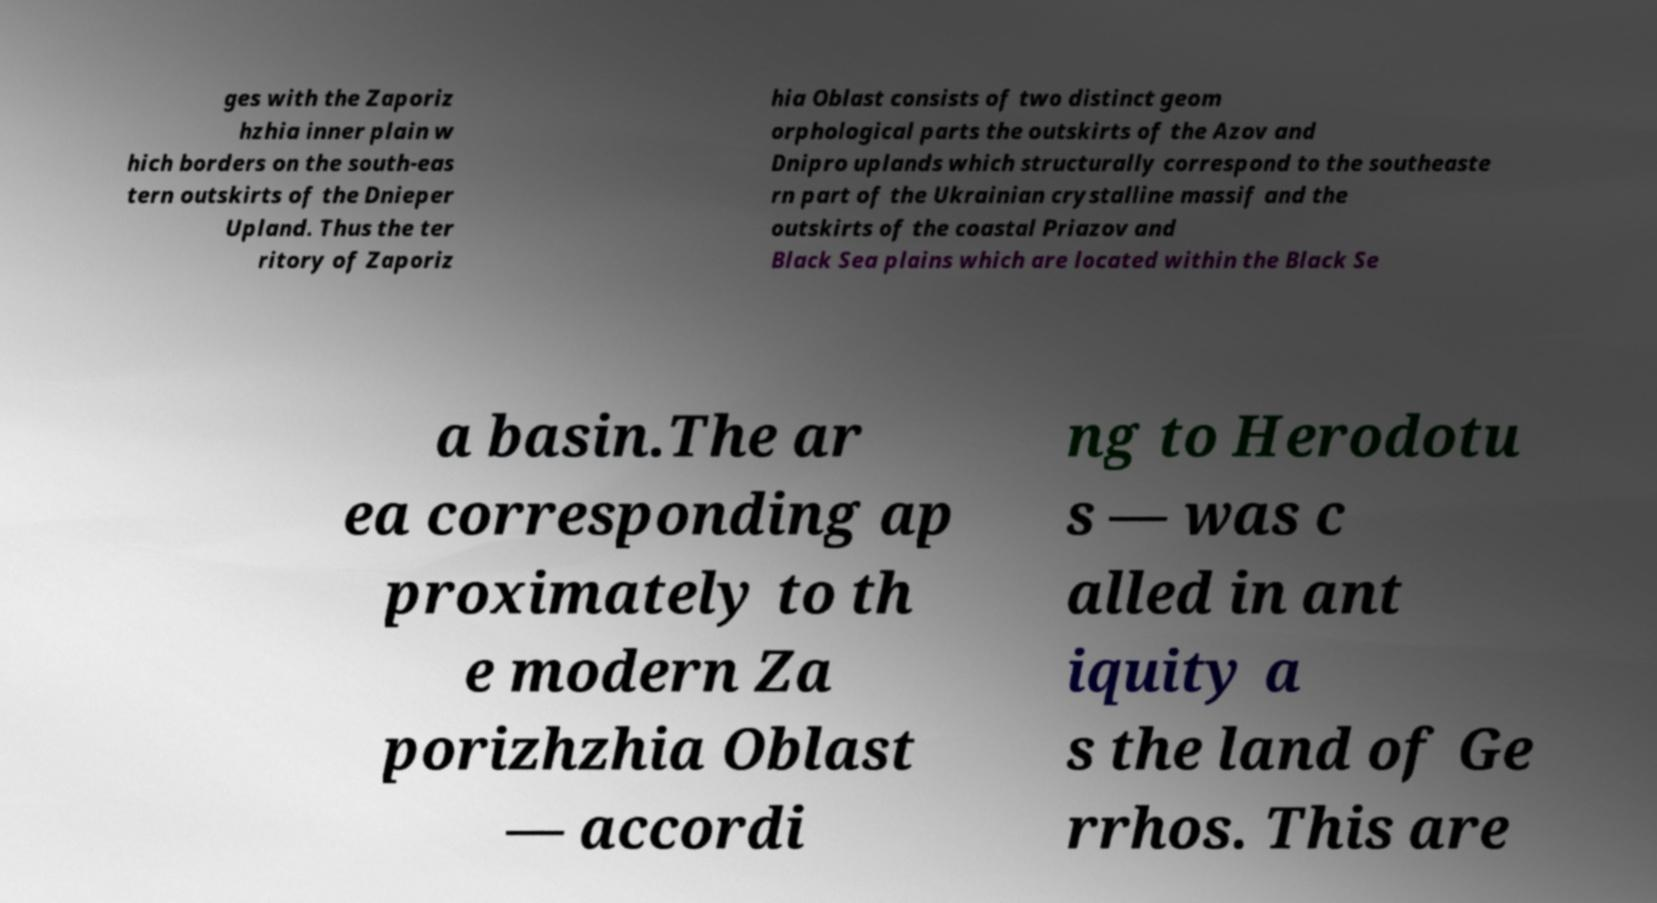For documentation purposes, I need the text within this image transcribed. Could you provide that? ges with the Zaporiz hzhia inner plain w hich borders on the south-eas tern outskirts of the Dnieper Upland. Thus the ter ritory of Zaporiz hia Oblast consists of two distinct geom orphological parts the outskirts of the Azov and Dnipro uplands which structurally correspond to the southeaste rn part of the Ukrainian crystalline massif and the outskirts of the coastal Priazov and Black Sea plains which are located within the Black Se a basin.The ar ea corresponding ap proximately to th e modern Za porizhzhia Oblast — accordi ng to Herodotu s — was c alled in ant iquity a s the land of Ge rrhos. This are 